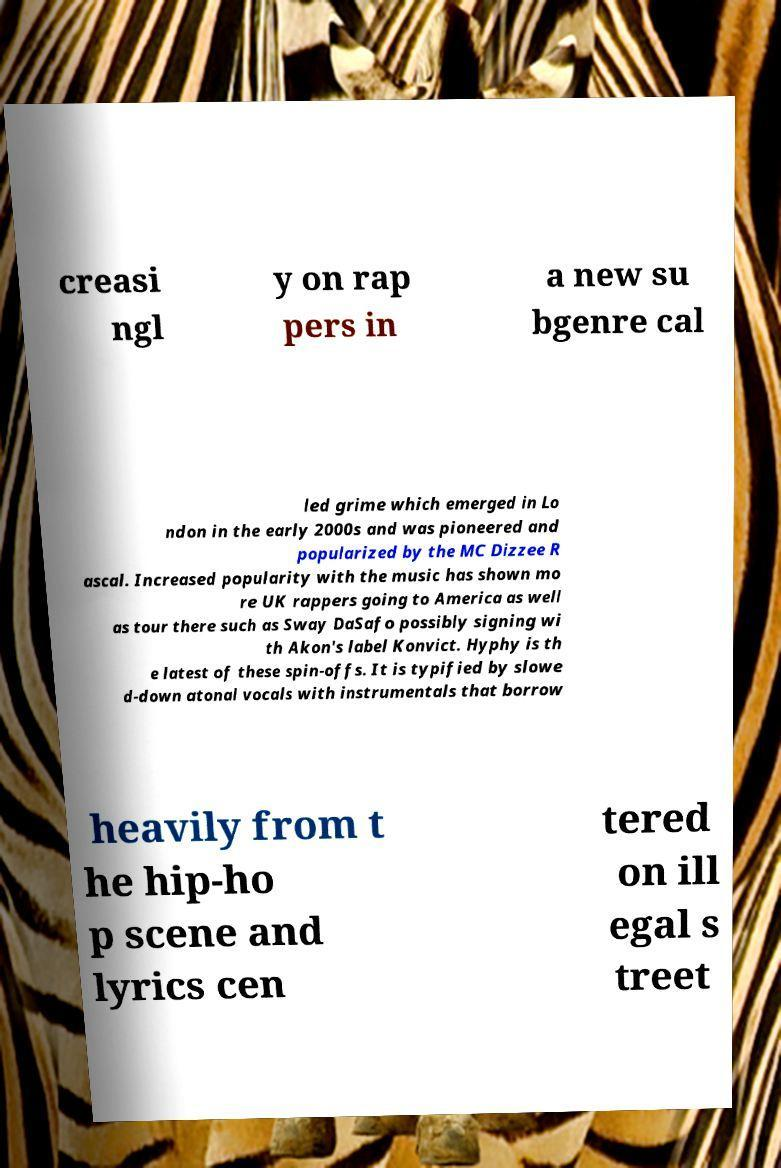Could you extract and type out the text from this image? creasi ngl y on rap pers in a new su bgenre cal led grime which emerged in Lo ndon in the early 2000s and was pioneered and popularized by the MC Dizzee R ascal. Increased popularity with the music has shown mo re UK rappers going to America as well as tour there such as Sway DaSafo possibly signing wi th Akon's label Konvict. Hyphy is th e latest of these spin-offs. It is typified by slowe d-down atonal vocals with instrumentals that borrow heavily from t he hip-ho p scene and lyrics cen tered on ill egal s treet 